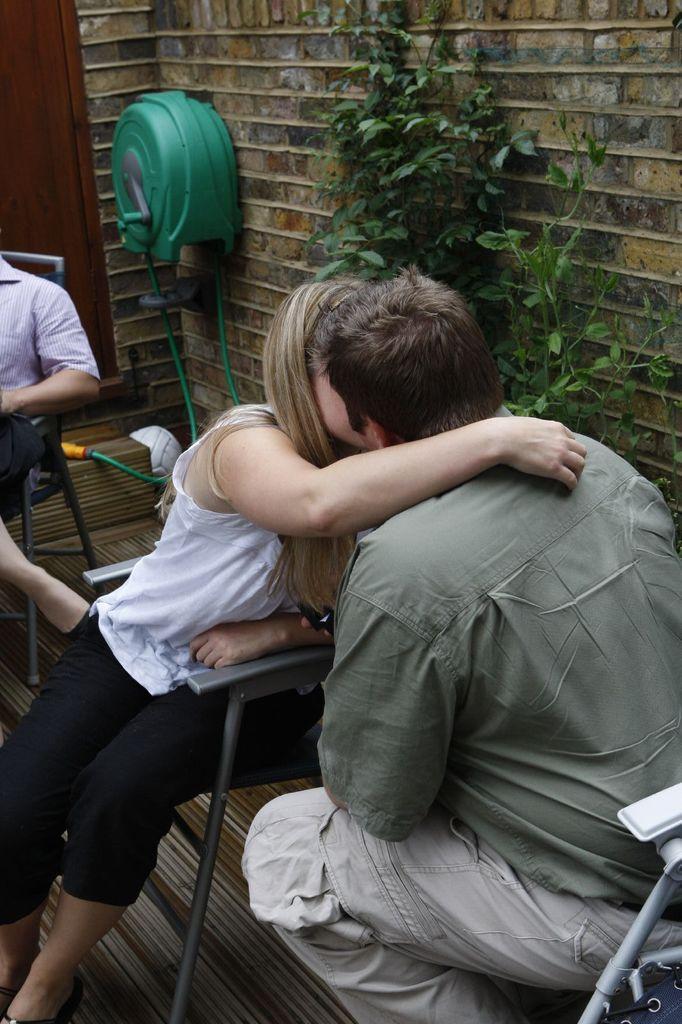Can you describe this image briefly? Here is the man and woman sitting on the chairs. I can see a green color object attached to the wall. This is a plant. I think this is a wooden door. At the left corner of the image I can see a person sitting on the chair. 